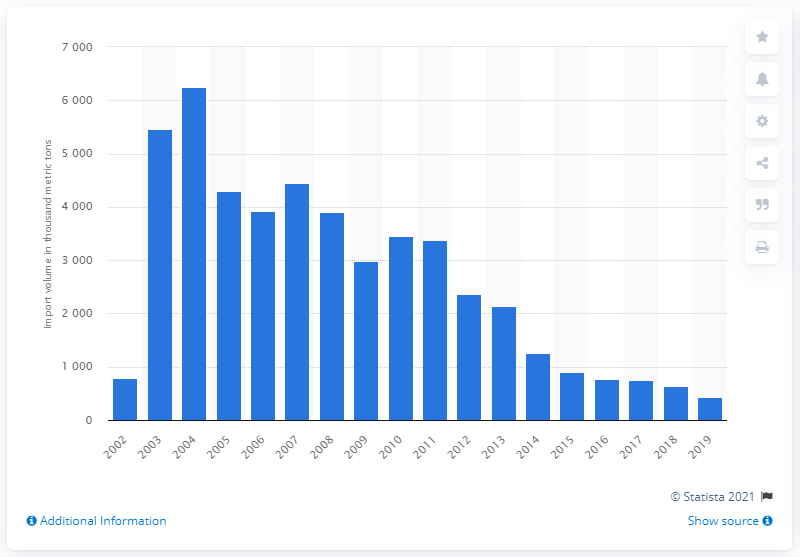Highlight a few significant elements in this photo. Coal imports from Australia peaked in 2004. In 2002, coal imports from Australia began to increase in the UK. 